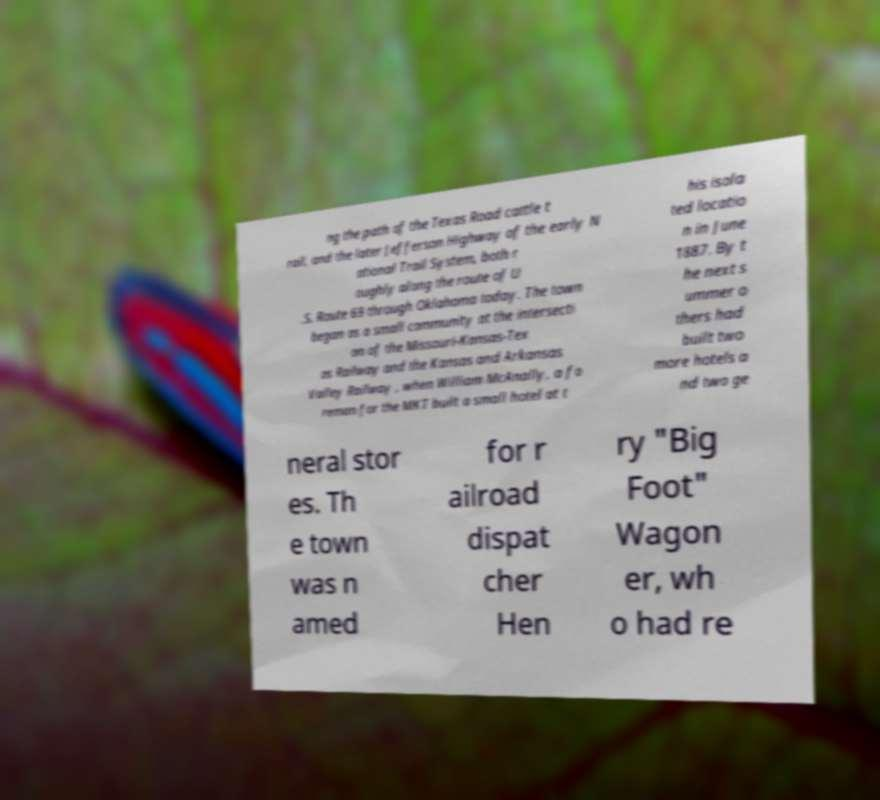There's text embedded in this image that I need extracted. Can you transcribe it verbatim? ng the path of the Texas Road cattle t rail, and the later Jefferson Highway of the early N ational Trail System, both r oughly along the route of U .S. Route 69 through Oklahoma today. The town began as a small community at the intersecti on of the Missouri-Kansas-Tex as Railway and the Kansas and Arkansas Valley Railway , when William McAnally, a fo reman for the MKT built a small hotel at t his isola ted locatio n in June 1887. By t he next s ummer o thers had built two more hotels a nd two ge neral stor es. Th e town was n amed for r ailroad dispat cher Hen ry "Big Foot" Wagon er, wh o had re 